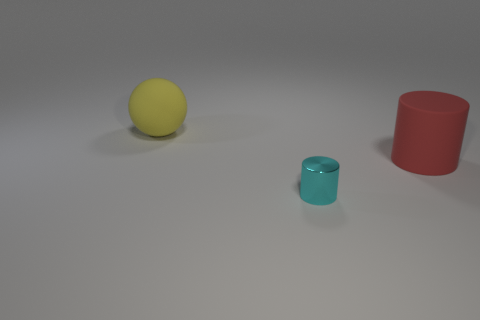Add 1 big rubber balls. How many objects exist? 4 Subtract all cylinders. How many objects are left? 1 Subtract 0 purple cylinders. How many objects are left? 3 Subtract all blue blocks. Subtract all cyan metallic cylinders. How many objects are left? 2 Add 2 cyan cylinders. How many cyan cylinders are left? 3 Add 2 purple metallic cylinders. How many purple metallic cylinders exist? 2 